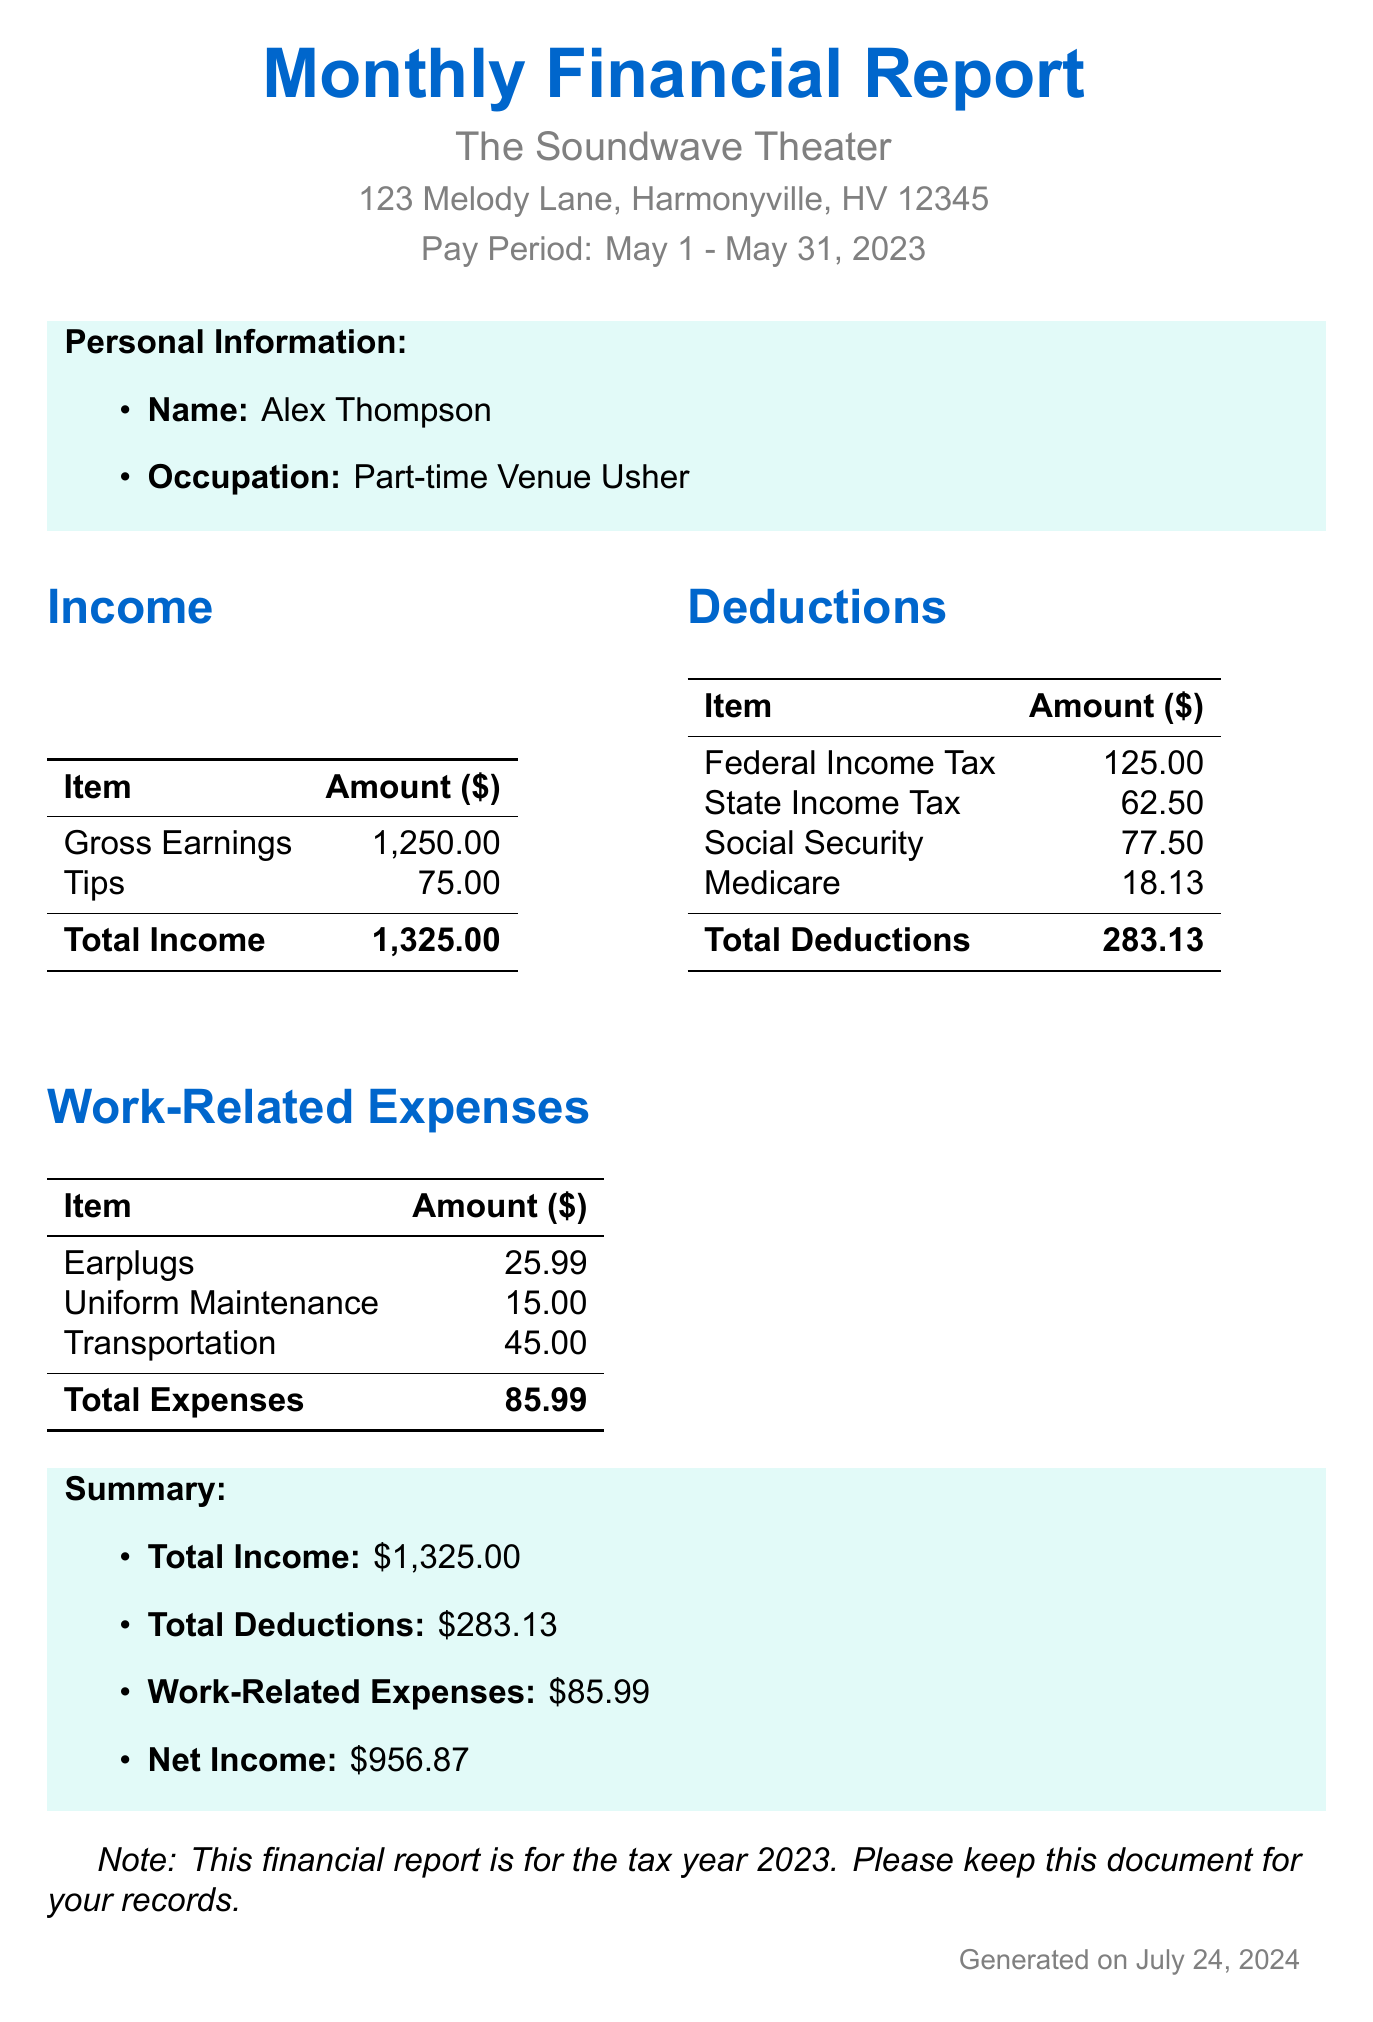What is the name of the venue? The venue listed in the document is where the usher works part-time, which is The Soundwave Theater.
Answer: The Soundwave Theater What is the gross earnings for the month? Gross earnings are stated separately in the income section, which is $1,250.00.
Answer: 1250.00 How much did federal income tax account for? The document specifies the federal income tax deduction clearly listed under deductions, which is $125.00.
Answer: 125.00 What is the total of work-related expenses? The total for work-related expenses is calculated from the individual expenses listed, which amounts to $85.99.
Answer: 85.99 What is the net income after deductions? The net income is calculated by subtracting total deductions and work-related expenses from total income, resulting in $956.87.
Answer: 956.87 How many hours did Alex work in the month? The number of hours worked is listed in the monthly income section, which is 62 hours.
Answer: 62 What percentage of tips contributed to total income? Tips are a part of the total income, and the calculation shows they were $75.00 out of $1,325.00 total income, which is approximately 5.66%.
Answer: 5.66% What is the total amount for state income tax? The state income tax is listed in the document under deductions, showing $62.50.
Answer: 62.50 What is the tax year referenced in the report? The document specifically indicates the tax year as 2023.
Answer: 2023 